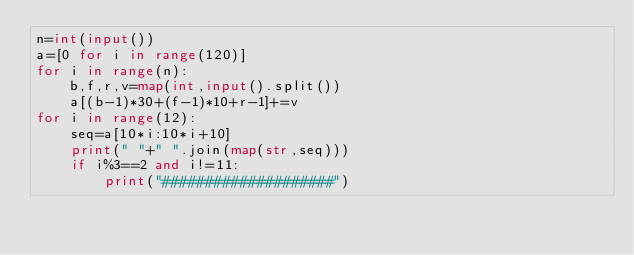<code> <loc_0><loc_0><loc_500><loc_500><_Python_>n=int(input())
a=[0 for i in range(120)]
for i in range(n):
    b,f,r,v=map(int,input().split())
    a[(b-1)*30+(f-1)*10+r-1]+=v
for i in range(12):
    seq=a[10*i:10*i+10]
    print(" "+" ".join(map(str,seq)))
    if i%3==2 and i!=11:
        print("####################")
</code> 